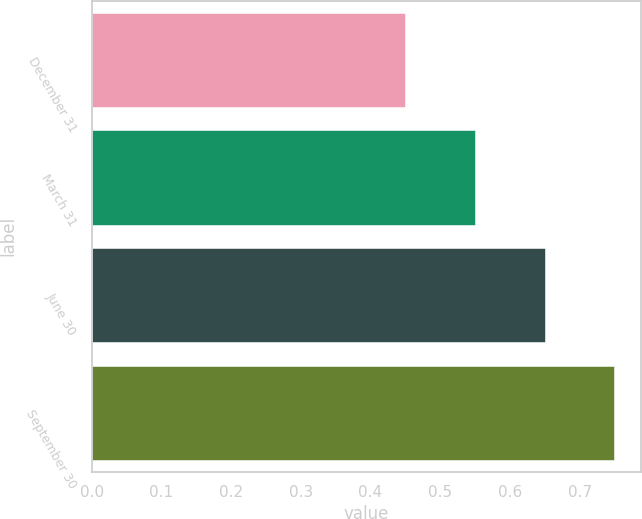<chart> <loc_0><loc_0><loc_500><loc_500><bar_chart><fcel>December 31<fcel>March 31<fcel>June 30<fcel>September 30<nl><fcel>0.45<fcel>0.55<fcel>0.65<fcel>0.75<nl></chart> 